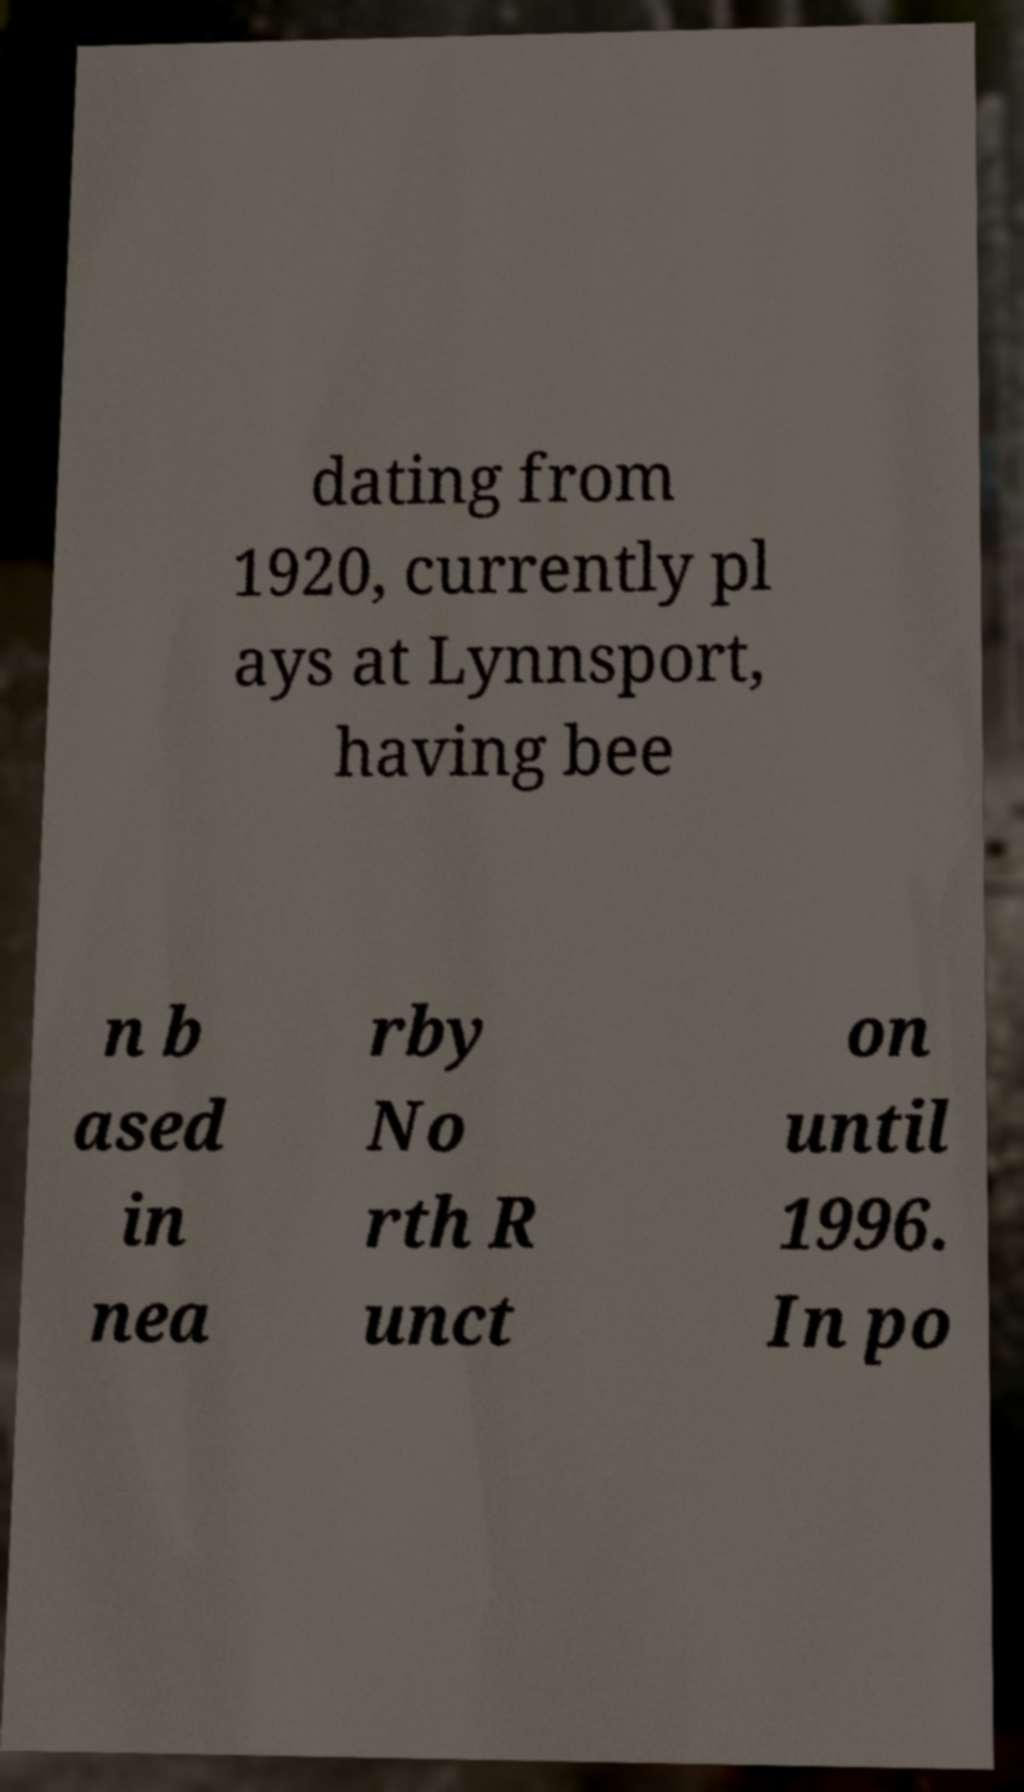Can you read and provide the text displayed in the image?This photo seems to have some interesting text. Can you extract and type it out for me? dating from 1920, currently pl ays at Lynnsport, having bee n b ased in nea rby No rth R unct on until 1996. In po 